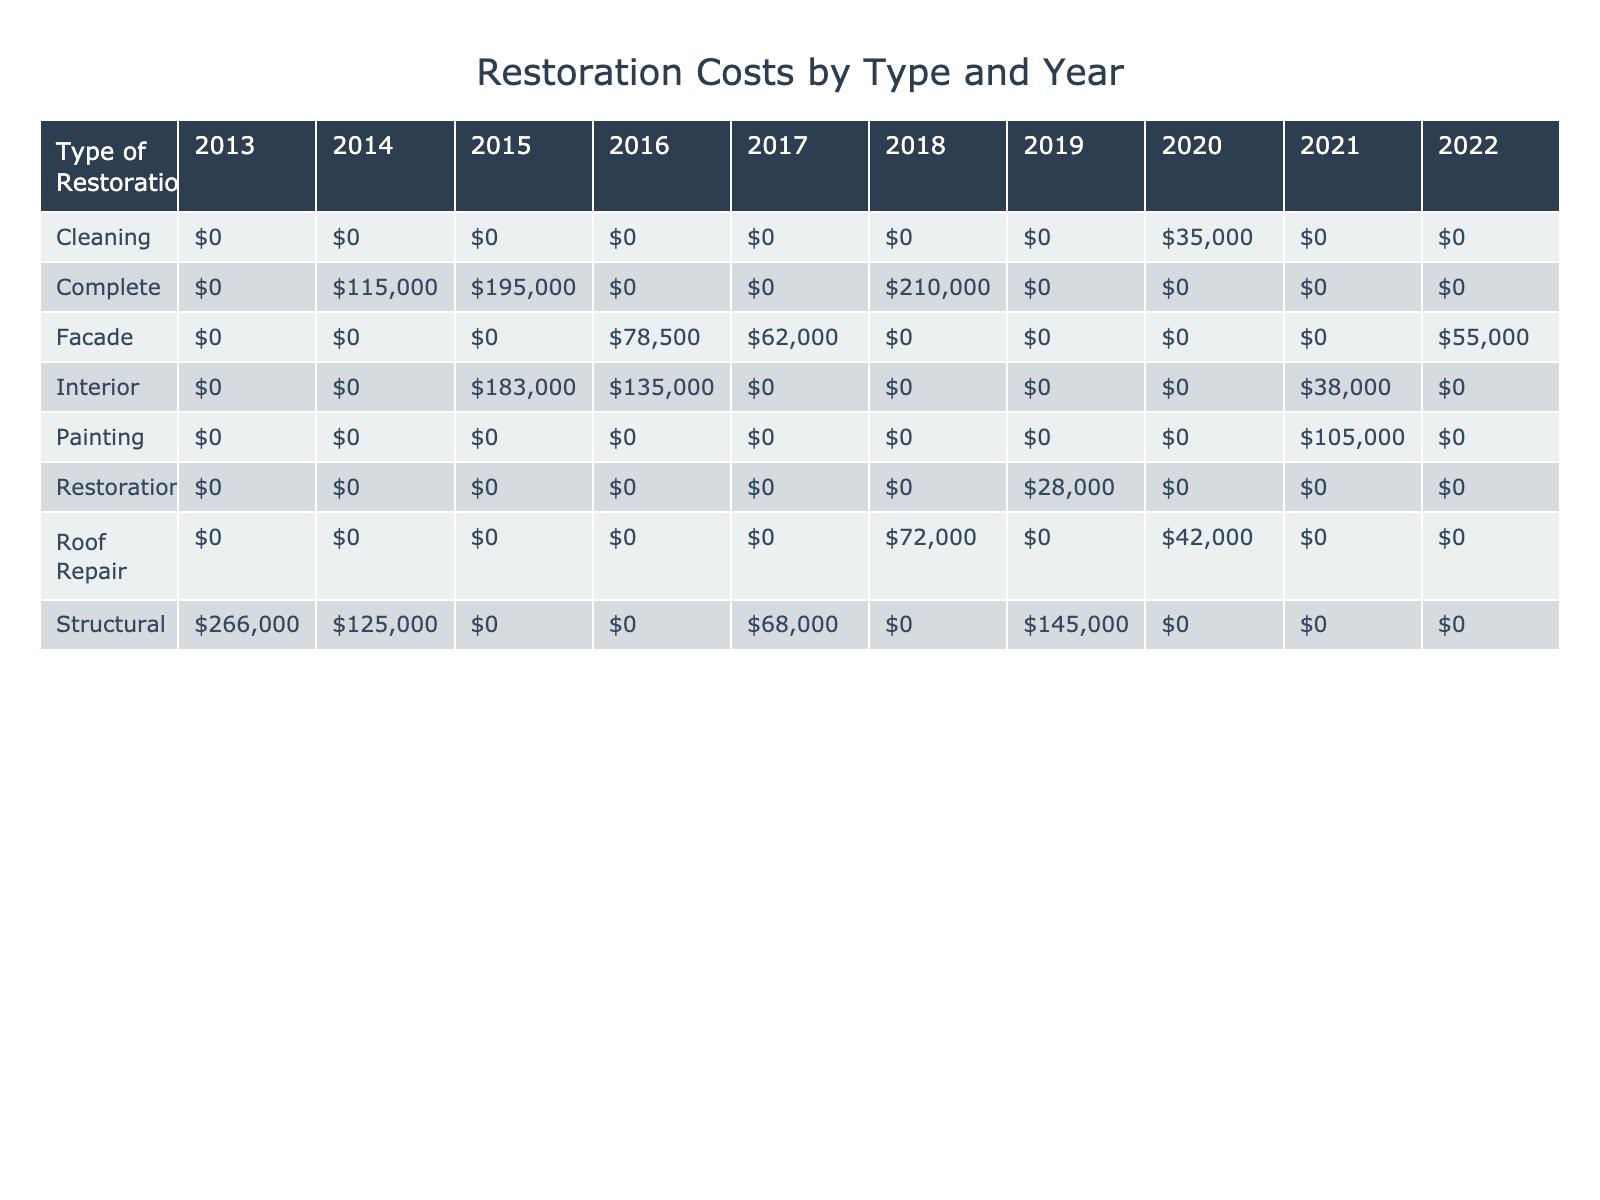What was the highest restoration cost recorded in 2018? In 2018, there are two restoration costs listed: $210,000 for the Culkin Railroad Depot (Complete) and $72,000 for the Culkin Fire Station (Roof Repair). The highest cost is $210,000.
Answer: $210,000 How much did the Culkin Cotton Gin restoration cost compared to the Culkin Schoolhouse restoration? The Culkin Cotton Gin restoration cost $78,500 while the Culkin Schoolhouse restoration cost $62,000. To compare, we find the difference: $78,500 - $62,000 = $16,500.
Answer: $16,500 Were any restoration projects funded by the Federal Postal Service? The table lists the Culkin Post Office (2022) as a restoration project funded by the Federal Postal Service, confirming that there was indeed at least one project funded by this source.
Answer: Yes What is the total restoration cost for structural restorations over the decade? To calculate the total for structural restorations, we look at the relevant rows: Old Culkin Courthouse ($125,000), Magnolia Plantation House ($180,000), Culkin Bridge ($145,000), Culkin Masonic Lodge ($68,000), and Culkin Covered Bridge ($86,000). Adding these gives us: $125,000 + $180,000 + $145,000 + $68,000 + $86,000 = $604,000.
Answer: $604,000 How many restoration projects were completed in 2014? In 2014, two restoration projects are listed: Old Culkin Courthouse (costing $125,000) and Culkin Town Hall (costing $115,000). Thus, there were two completed projects in that year.
Answer: 2 What was the average restoration cost for interior restoration types over the decade? The interior restoration costs listed are: St. Mary's Church ($95,000), Culkin Public Library ($88,000), Culkin Theater ($135,000), and Culkin Blacksmith Shop ($38,000). Their total is $95,000 + $88,000 + $135,000 + $38,000 = $356,000. There are 4 data points; dividing gives us an average of $356,000 / 4 = $89,000.
Answer: $89,000 Did any restoration projects cost less than $40,000, and if so, how many? Reviewing the table, the costs under $40,000 are: Confederate Memorial Statue ($35,000) and Culkin Cemetery Gates ($28,000), totaling two projects that cost less than $40,000.
Answer: 2 What was the total restoration cost for projects funded by the Municipal Budget? The projects funded by the Municipal Budget are: Old Culkin Courthouse ($125,000) and Culkin Water Tower ($105,000). Adding these amounts yields $125,000 + $105,000 = $230,000.
Answer: $230,000 